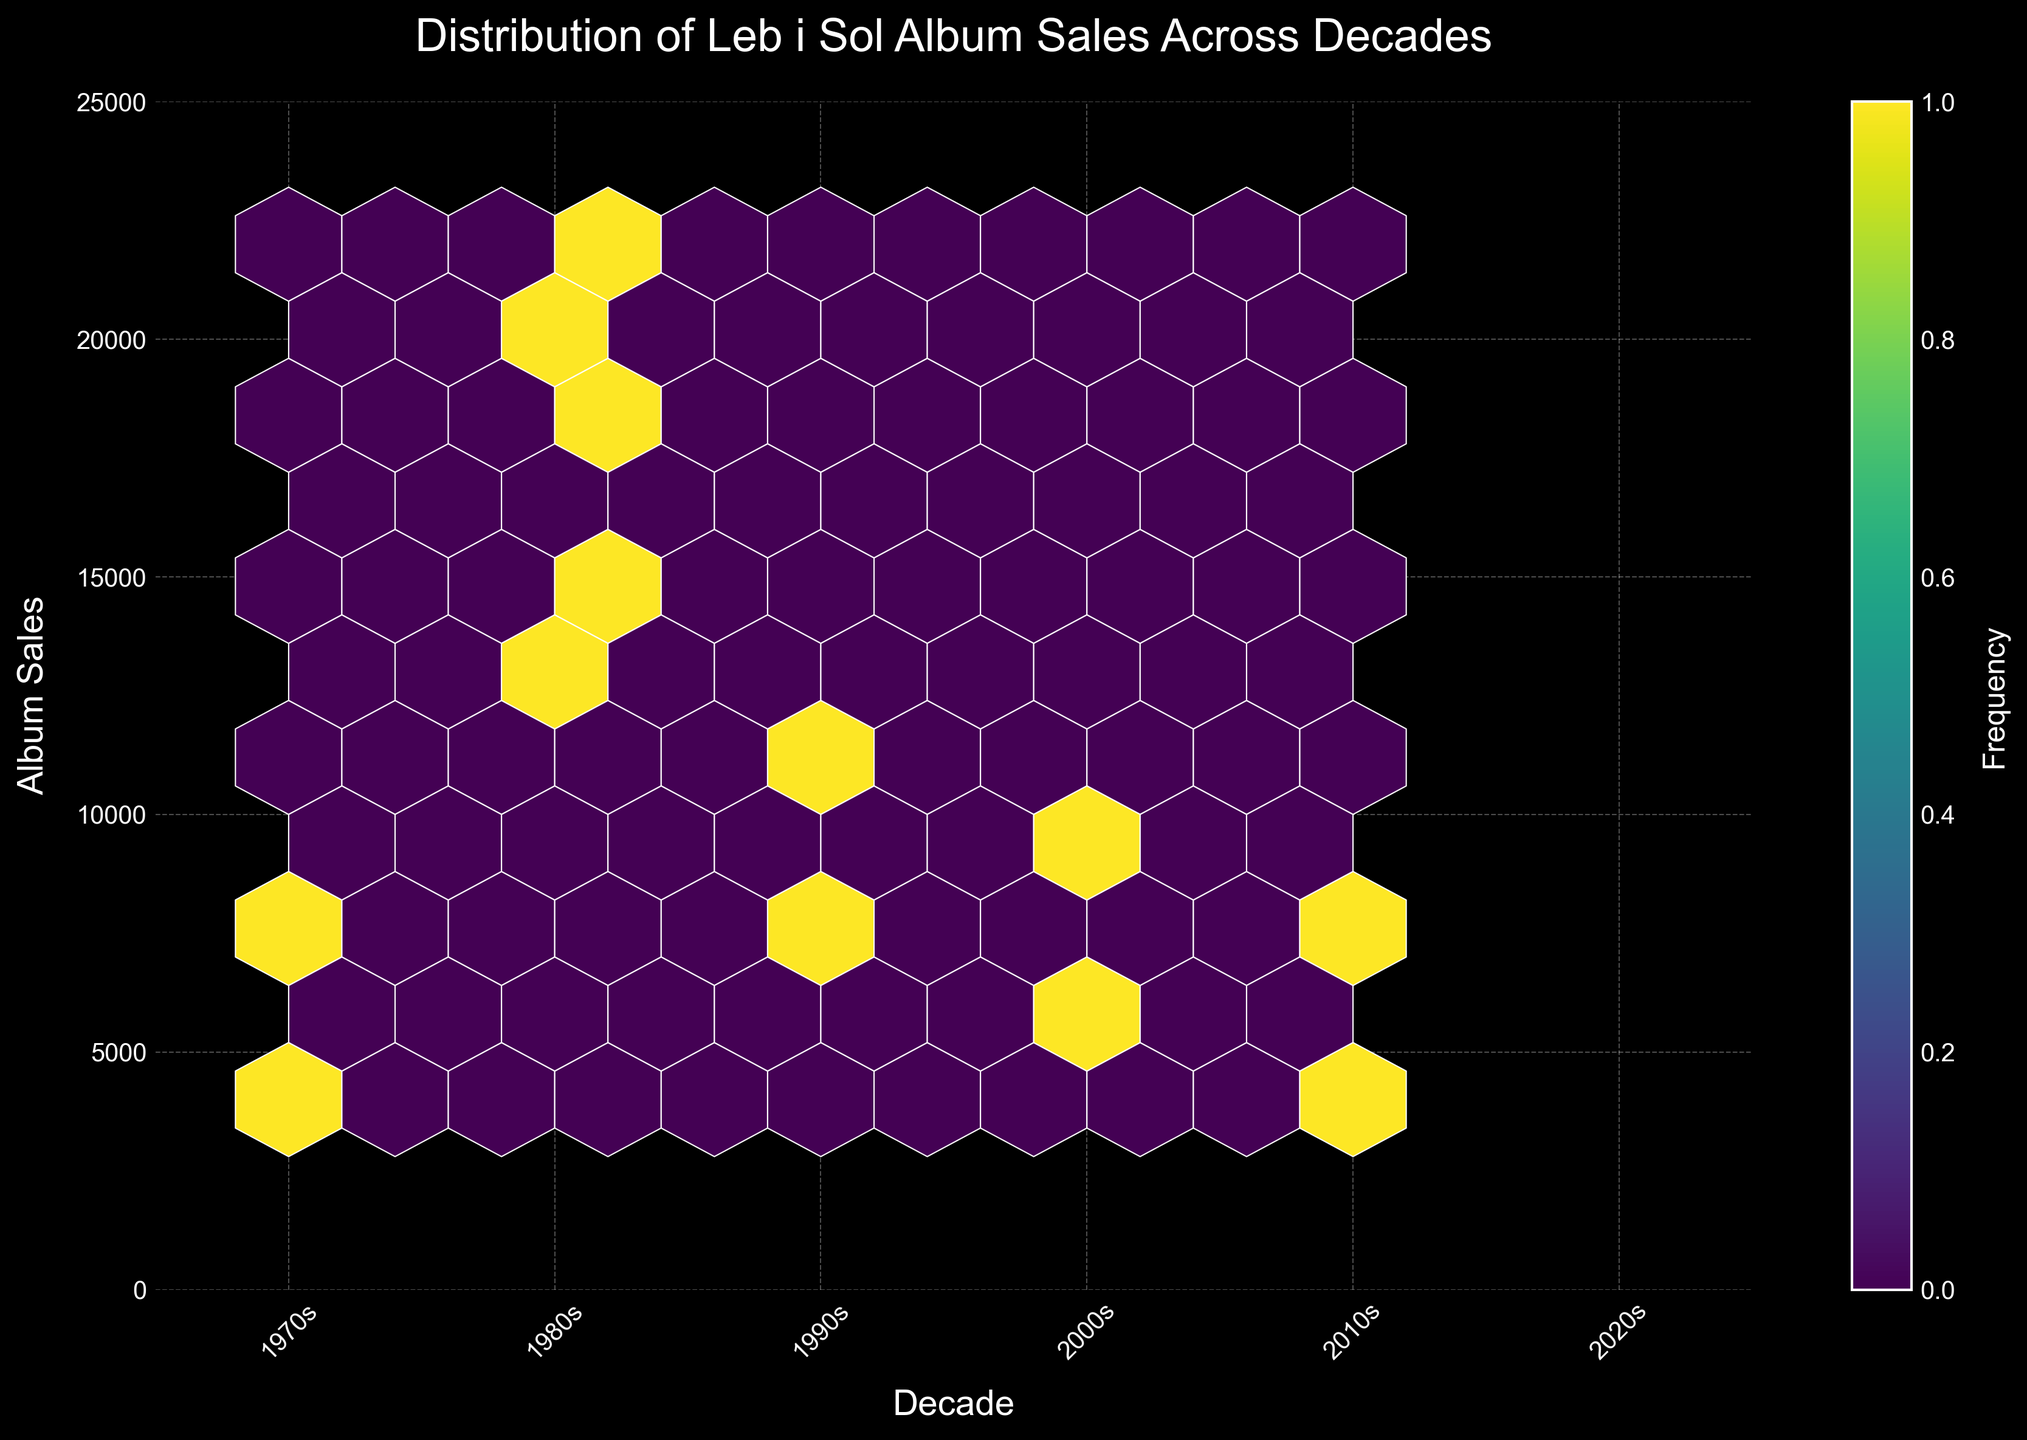Which decade has the highest album sales for Leb i Sol? Looking at the vertical distribution of sales and identifying the decade with the highest concentration and peak sales values, you'll see that the 1980s have the largest number of higher sales figures.
Answer: 1980s Between which decades did Leb i Sol experience a significant drop in album sales? Observe the trend between decades, noting that sales drop significantly from the 1980s to the 1990s, as evidenced by fewer points in higher sales bins.
Answer: From 1980s to 1990s What is the highest sales value observed in the 1980s? The scatter point (or points within a hexagon) at the top-most or near top of the graph in the 1980s region represents the highest sales figure, which is around 22,000 units.
Answer: 22,000 How does the number of albums sold in the 2010s compare to the 2000s? Comparing the density and location of hexagons in the 2010s and 2000s, the 2010s show fewer higher-value sales hexagons than the 2000s, indicating fewer album sales.
Answer: Fewer in the 2010s In which decade was Leb i Sol's least popular album sales-wise released? Check the bottom-most or less populated part of the hexbin plot for each decade. In the 2010s, the lowest sales (around 4,000) can be observed, indicating the least popular album.
Answer: 2010s What trend do you observe in Leb i Sol's album sales from the 1970s to the 2010s? Trace the progression of sales values across the decades on the x-axis and observe how sales rise through the 1980s but decline afterward toward the 2010s, showing an overall bell curve trend.
Answer: Increasing to the 1980s, then decreasing after What does the color intensity of the hexagons represent in the plot? The color intensity, ranging to a lighter tone, shows the concentration or frequency of data points; brighter hexagons indicate more frequent sales figures in that range.
Answer: Frequency of sales points How do album sales in the 1990s compare to those in the 1970s? Compare the density and vertical extent of hexagons in both decades. The 1990s show slightly lower hexagon elevation and fewer higher-density sales points compared to the 1980s.
Answer: Lower in the 1990s What is the width of each decade interval on the x-axis? The x-axis is marked in decades from the 1970s to the 2010s, making each interval 10 years wide.
Answer: 10 years How many hexagons are clearly visible in the 1980s? Count the outlined hexagonal bins in the plot region designated for the 1980s decade.
Answer: Several (over 5) 